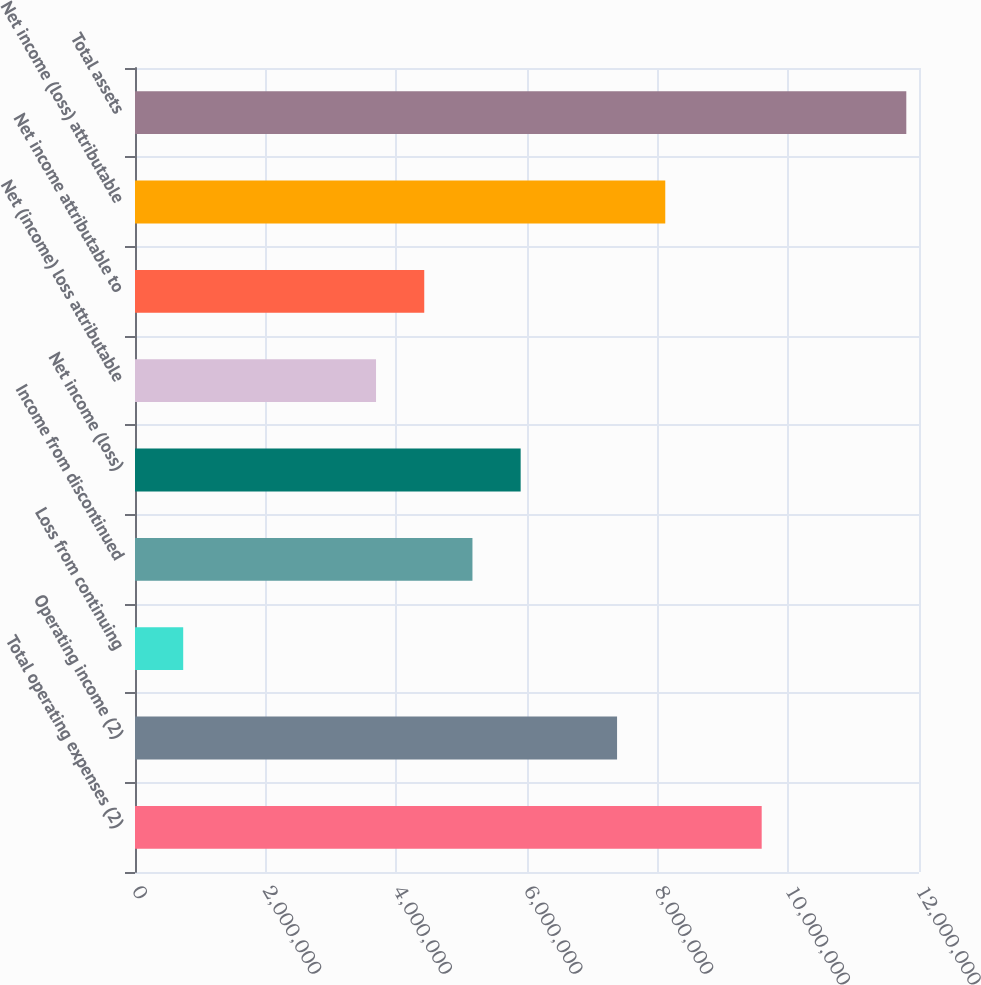Convert chart to OTSL. <chart><loc_0><loc_0><loc_500><loc_500><bar_chart><fcel>Total operating expenses (2)<fcel>Operating income (2)<fcel>Loss from continuing<fcel>Income from discontinued<fcel>Net income (loss)<fcel>Net (income) loss attributable<fcel>Net income attributable to<fcel>Net income (loss) attributable<fcel>Total assets<nl><fcel>9.59214e+06<fcel>7.37857e+06<fcel>737857<fcel>5.165e+06<fcel>5.90285e+06<fcel>3.68928e+06<fcel>4.42714e+06<fcel>8.11642e+06<fcel>1.18057e+07<nl></chart> 